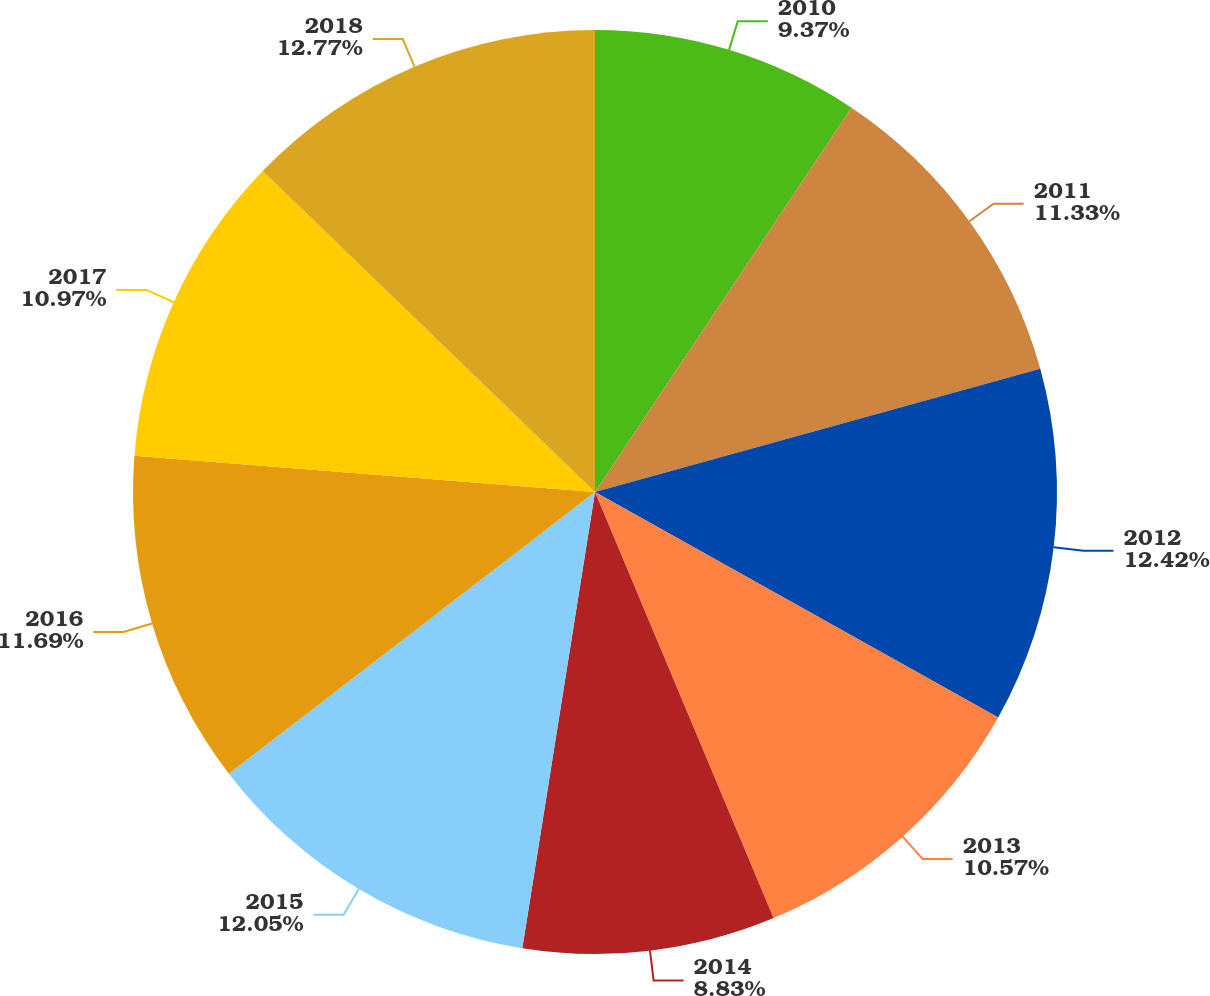Convert chart. <chart><loc_0><loc_0><loc_500><loc_500><pie_chart><fcel>2010<fcel>2011<fcel>2012<fcel>2013<fcel>2014<fcel>2015<fcel>2016<fcel>2017<fcel>2018<nl><fcel>9.37%<fcel>11.33%<fcel>12.42%<fcel>10.57%<fcel>8.83%<fcel>12.05%<fcel>11.69%<fcel>10.97%<fcel>12.78%<nl></chart> 